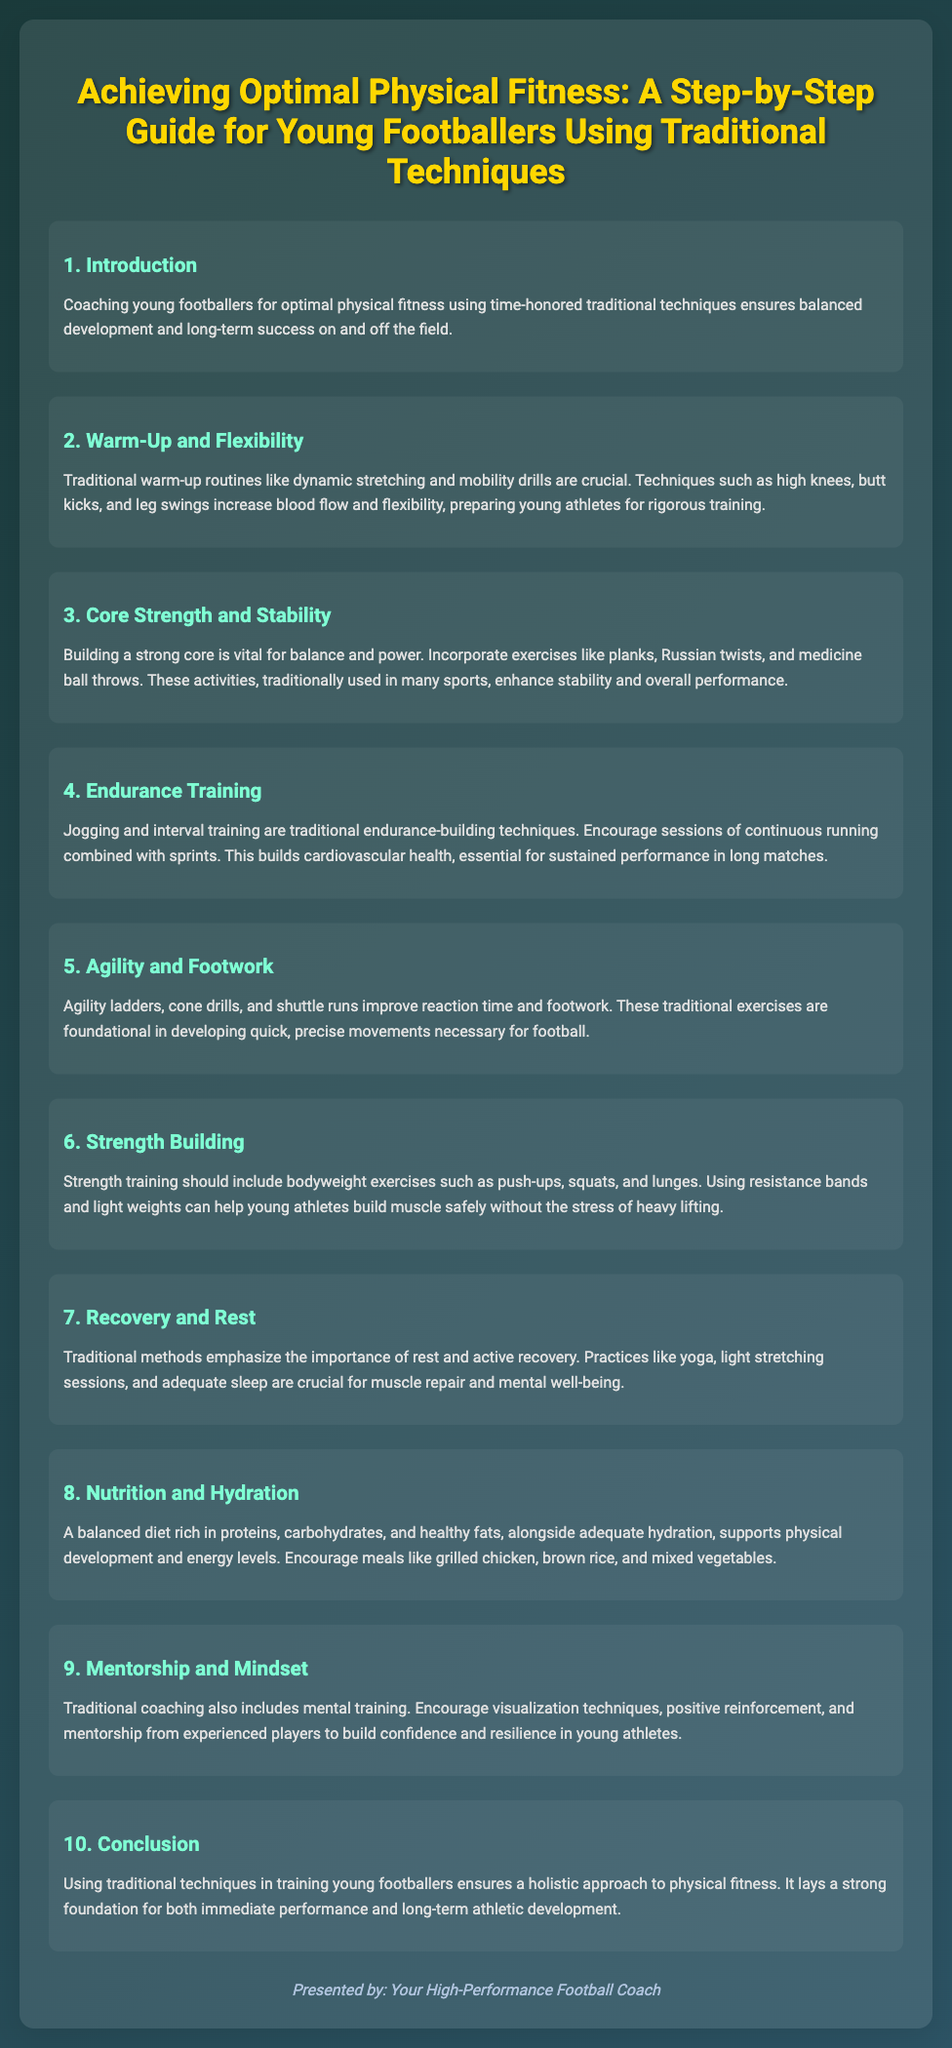What are traditional techniques used for warming up? The document lists warm-up techniques such as dynamic stretching, high knees, butt kicks, and leg swings that are traditional in nature.
Answer: Dynamic stretching, high knees, butt kicks, leg swings What is essential for cardiovascular health according to the slide? The document mentions that jogging and interval training are traditional techniques that help build endurance and are essential for cardiovascular health.
Answer: Jogging and interval training What should be included in strength training for young footballers? The document states that strength training should include bodyweight exercises such as push-ups, squats, and lunges, along with resistance bands and light weights.
Answer: Push-ups, squats, lunges What diet is encouraged for young footballers? The document recommends a diet rich in proteins, carbohydrates, and healthy fats, alongside meals like grilled chicken, brown rice, and mixed vegetables.
Answer: Grilled chicken, brown rice, mixed vegetables Why is core strength important for young athletes? The document explains that building a strong core is vital for balance and power, which enhances stability and overall performance.
Answer: Balance and power What traditional method is emphasized for recovery? The slide discusses the importance of rest and active recovery through methods such as yoga and light stretching for muscle repair and mental well-being.
Answer: Yoga, light stretching What role does mentorship play in young footballer training? The document highlights that traditional coaching includes mental training, where mentorship from experienced players helps build confidence and resilience.
Answer: Confidence and resilience Which exercise improves reaction time and footwork? The slide mentions agility ladders, cone drills, and shuttle runs as exercises that improve reaction time and footwork, which are fundamental in football.
Answer: Agility ladders, cone drills, shuttle runs What is the focus of the conclusion in the presentation? The conclusion states that using traditional techniques ensures a holistic approach to physical fitness, laying a strong foundation for athletic development.
Answer: Holistic approach to physical fitness 